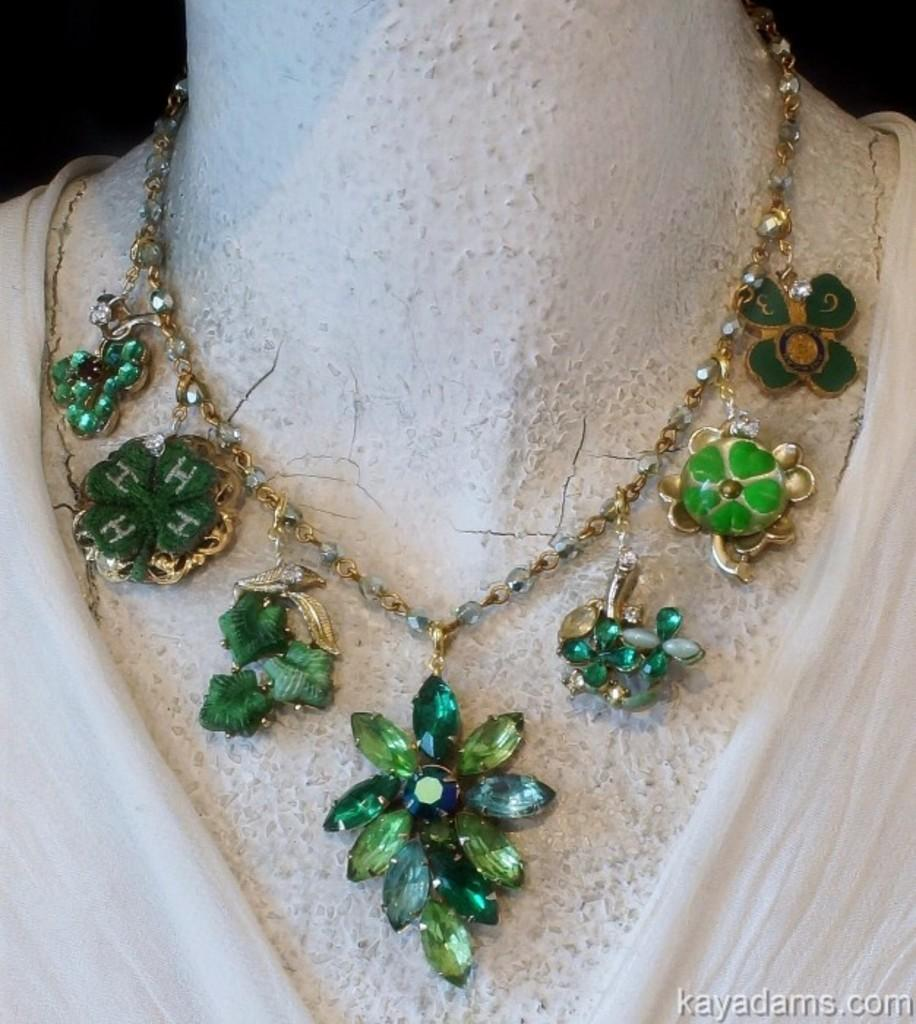What type of jewelry is present in the image? There is a necklace in the image. Where is the necklace placed in the image? The necklace is on a mannequin. What type of bread is being used to hold the gate open in the image? There is no bread or gate present in the image; it only features a necklace on a mannequin. 